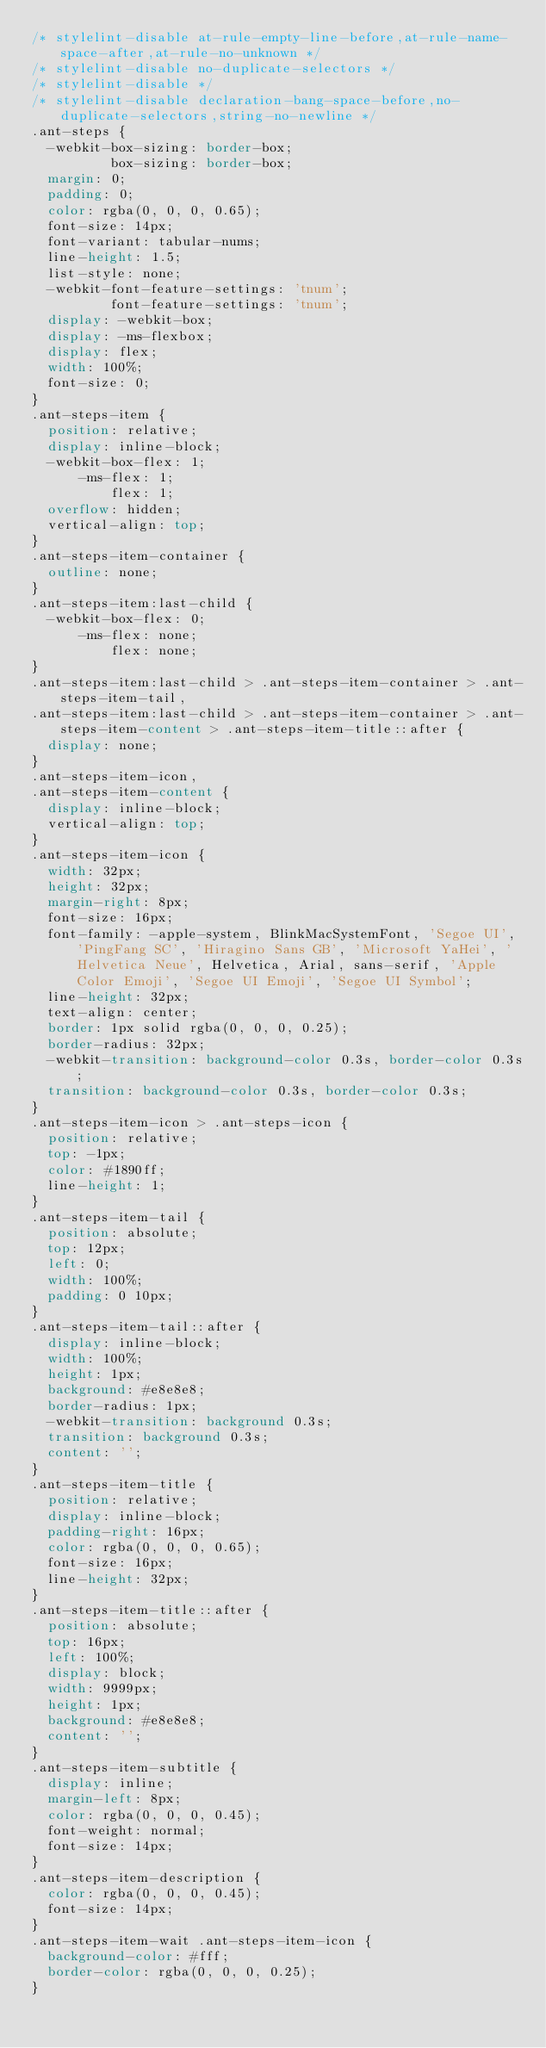Convert code to text. <code><loc_0><loc_0><loc_500><loc_500><_CSS_>/* stylelint-disable at-rule-empty-line-before,at-rule-name-space-after,at-rule-no-unknown */
/* stylelint-disable no-duplicate-selectors */
/* stylelint-disable */
/* stylelint-disable declaration-bang-space-before,no-duplicate-selectors,string-no-newline */
.ant-steps {
  -webkit-box-sizing: border-box;
          box-sizing: border-box;
  margin: 0;
  padding: 0;
  color: rgba(0, 0, 0, 0.65);
  font-size: 14px;
  font-variant: tabular-nums;
  line-height: 1.5;
  list-style: none;
  -webkit-font-feature-settings: 'tnum';
          font-feature-settings: 'tnum';
  display: -webkit-box;
  display: -ms-flexbox;
  display: flex;
  width: 100%;
  font-size: 0;
}
.ant-steps-item {
  position: relative;
  display: inline-block;
  -webkit-box-flex: 1;
      -ms-flex: 1;
          flex: 1;
  overflow: hidden;
  vertical-align: top;
}
.ant-steps-item-container {
  outline: none;
}
.ant-steps-item:last-child {
  -webkit-box-flex: 0;
      -ms-flex: none;
          flex: none;
}
.ant-steps-item:last-child > .ant-steps-item-container > .ant-steps-item-tail,
.ant-steps-item:last-child > .ant-steps-item-container > .ant-steps-item-content > .ant-steps-item-title::after {
  display: none;
}
.ant-steps-item-icon,
.ant-steps-item-content {
  display: inline-block;
  vertical-align: top;
}
.ant-steps-item-icon {
  width: 32px;
  height: 32px;
  margin-right: 8px;
  font-size: 16px;
  font-family: -apple-system, BlinkMacSystemFont, 'Segoe UI', 'PingFang SC', 'Hiragino Sans GB', 'Microsoft YaHei', 'Helvetica Neue', Helvetica, Arial, sans-serif, 'Apple Color Emoji', 'Segoe UI Emoji', 'Segoe UI Symbol';
  line-height: 32px;
  text-align: center;
  border: 1px solid rgba(0, 0, 0, 0.25);
  border-radius: 32px;
  -webkit-transition: background-color 0.3s, border-color 0.3s;
  transition: background-color 0.3s, border-color 0.3s;
}
.ant-steps-item-icon > .ant-steps-icon {
  position: relative;
  top: -1px;
  color: #1890ff;
  line-height: 1;
}
.ant-steps-item-tail {
  position: absolute;
  top: 12px;
  left: 0;
  width: 100%;
  padding: 0 10px;
}
.ant-steps-item-tail::after {
  display: inline-block;
  width: 100%;
  height: 1px;
  background: #e8e8e8;
  border-radius: 1px;
  -webkit-transition: background 0.3s;
  transition: background 0.3s;
  content: '';
}
.ant-steps-item-title {
  position: relative;
  display: inline-block;
  padding-right: 16px;
  color: rgba(0, 0, 0, 0.65);
  font-size: 16px;
  line-height: 32px;
}
.ant-steps-item-title::after {
  position: absolute;
  top: 16px;
  left: 100%;
  display: block;
  width: 9999px;
  height: 1px;
  background: #e8e8e8;
  content: '';
}
.ant-steps-item-subtitle {
  display: inline;
  margin-left: 8px;
  color: rgba(0, 0, 0, 0.45);
  font-weight: normal;
  font-size: 14px;
}
.ant-steps-item-description {
  color: rgba(0, 0, 0, 0.45);
  font-size: 14px;
}
.ant-steps-item-wait .ant-steps-item-icon {
  background-color: #fff;
  border-color: rgba(0, 0, 0, 0.25);
}</code> 